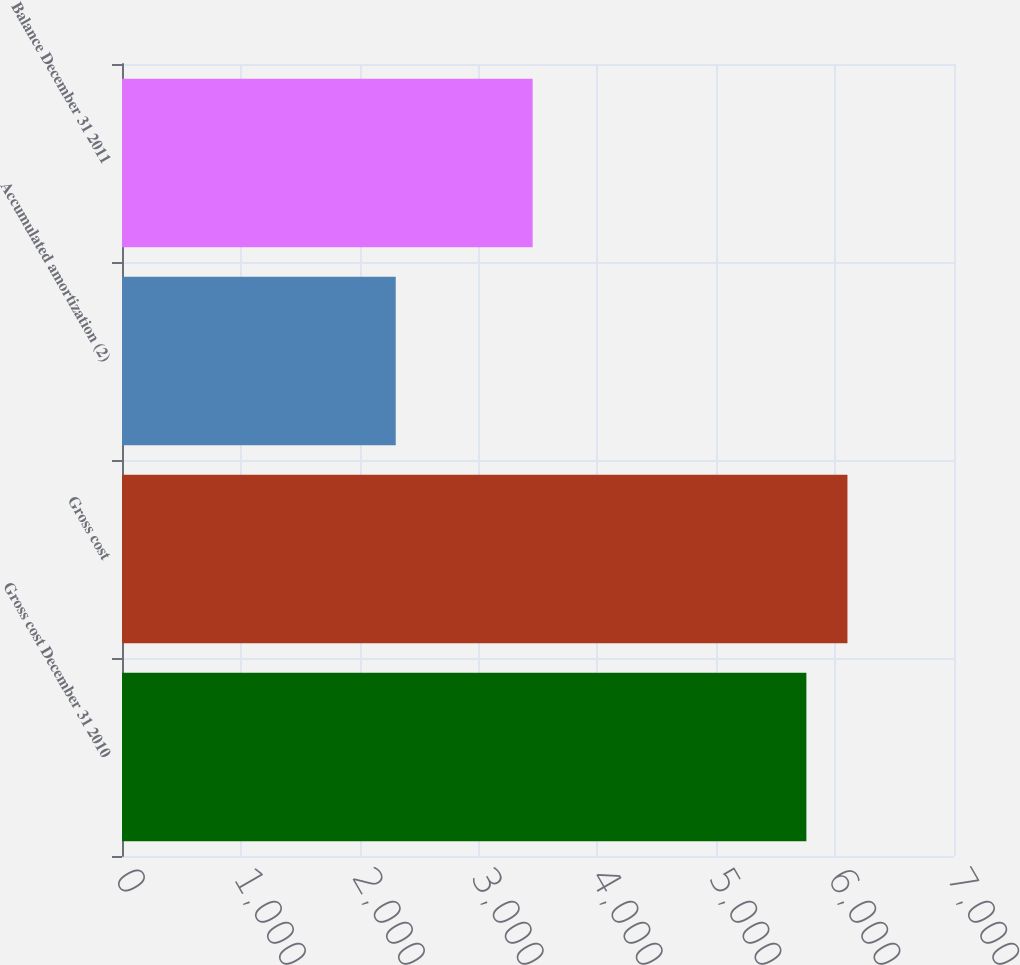Convert chart. <chart><loc_0><loc_0><loc_500><loc_500><bar_chart><fcel>Gross cost December 31 2010<fcel>Gross cost<fcel>Accumulated amortization (2)<fcel>Balance December 31 2011<nl><fcel>5758<fcel>6103.5<fcel>2303<fcel>3455<nl></chart> 